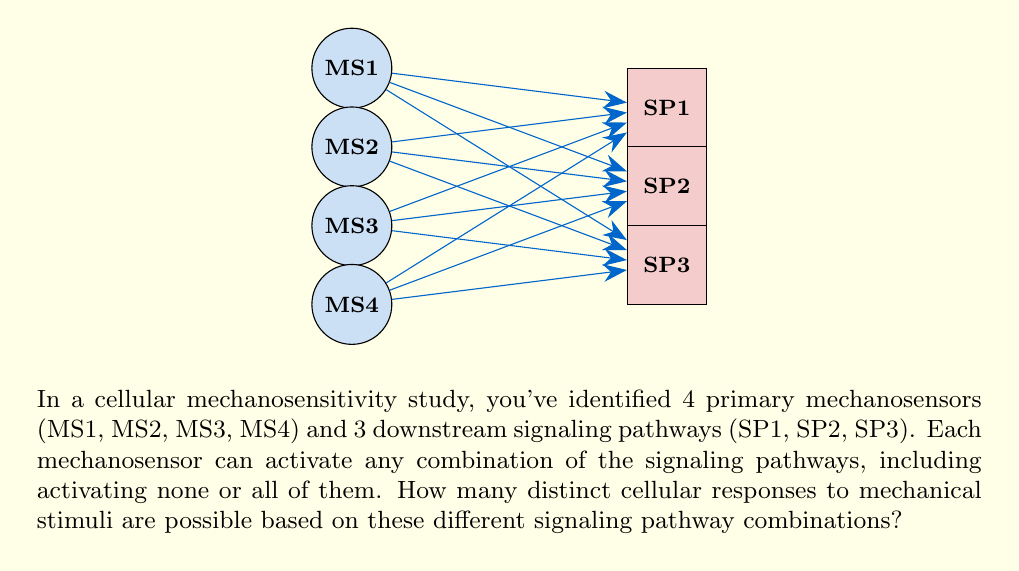Can you solve this math problem? Let's approach this step-by-step:

1) First, let's consider a single mechanosensor. For each signaling pathway, it has two options: activate or not activate.

2) With 3 signaling pathways, each mechanosensor has $2^3 = 8$ possible activation patterns:
   - Activate none: $\{0,0,0\}$
   - Activate only SP1: $\{1,0,0\}$
   - Activate only SP2: $\{0,1,0\}$
   - Activate only SP3: $\{0,0,1\}$
   - Activate SP1 and SP2: $\{1,1,0\}$
   - Activate SP1 and SP3: $\{1,0,1\}$
   - Activate SP2 and SP3: $\{0,1,1\}$
   - Activate all: $\{1,1,1\}$

3) Now, we have 4 independent mechanosensors, each with 8 possible activation patterns.

4) The total number of distinct cellular responses is the number of ways these independent choices can be combined.

5) This is a perfect scenario for applying the multiplication principle of combinatorics. If we have $n$ independent events, and each event $i$ can occur in $m_i$ ways, then the total number of ways all events can occur is the product $m_1 \times m_2 \times ... \times m_n$.

6) In our case, we have 4 independent events (the mechanosensors), each with 8 possible outcomes.

7) Therefore, the total number of distinct cellular responses is:

   $$ 8 \times 8 \times 8 \times 8 = 8^4 = 4096 $$

Thus, there are 4096 distinct cellular responses possible based on the different signaling pathway combinations.
Answer: $8^4 = 4096$ 